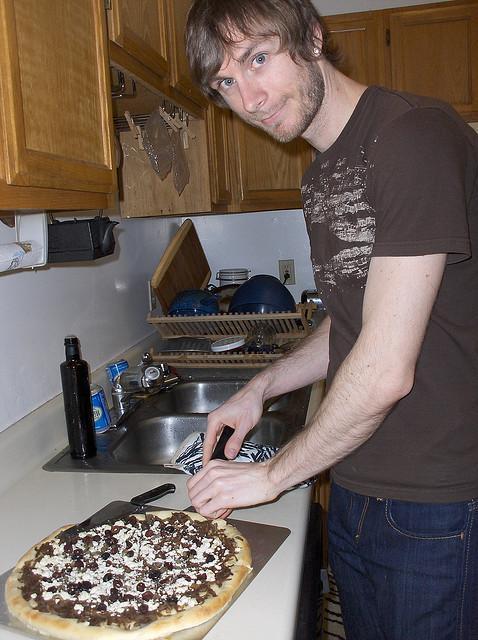Is the given caption "The person is touching the pizza." fitting for the image?
Answer yes or no. Yes. 